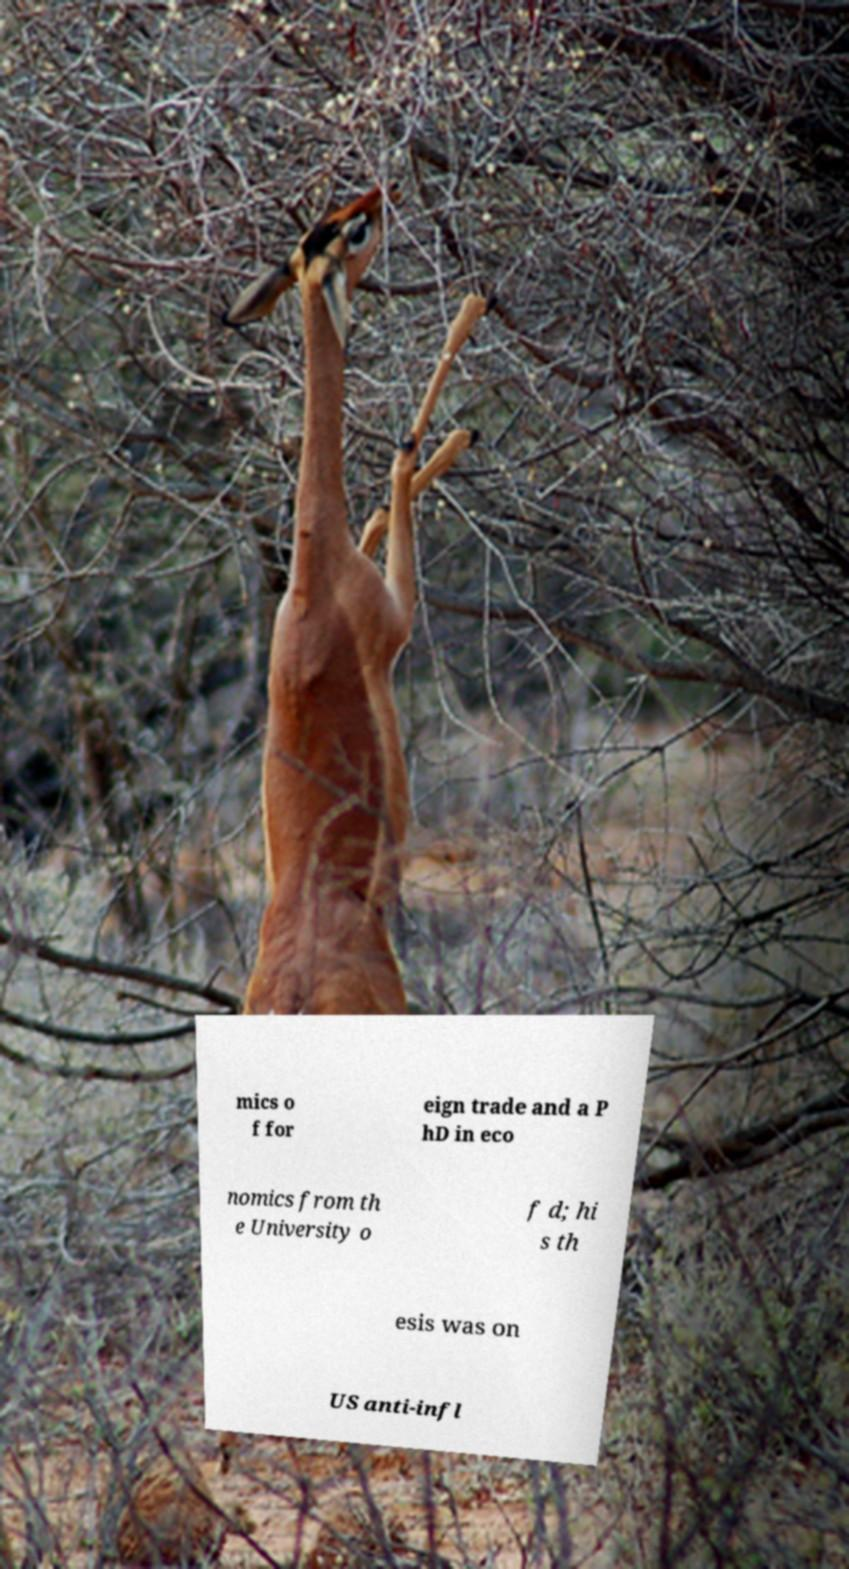What messages or text are displayed in this image? I need them in a readable, typed format. mics o f for eign trade and a P hD in eco nomics from th e University o f d; hi s th esis was on US anti-infl 